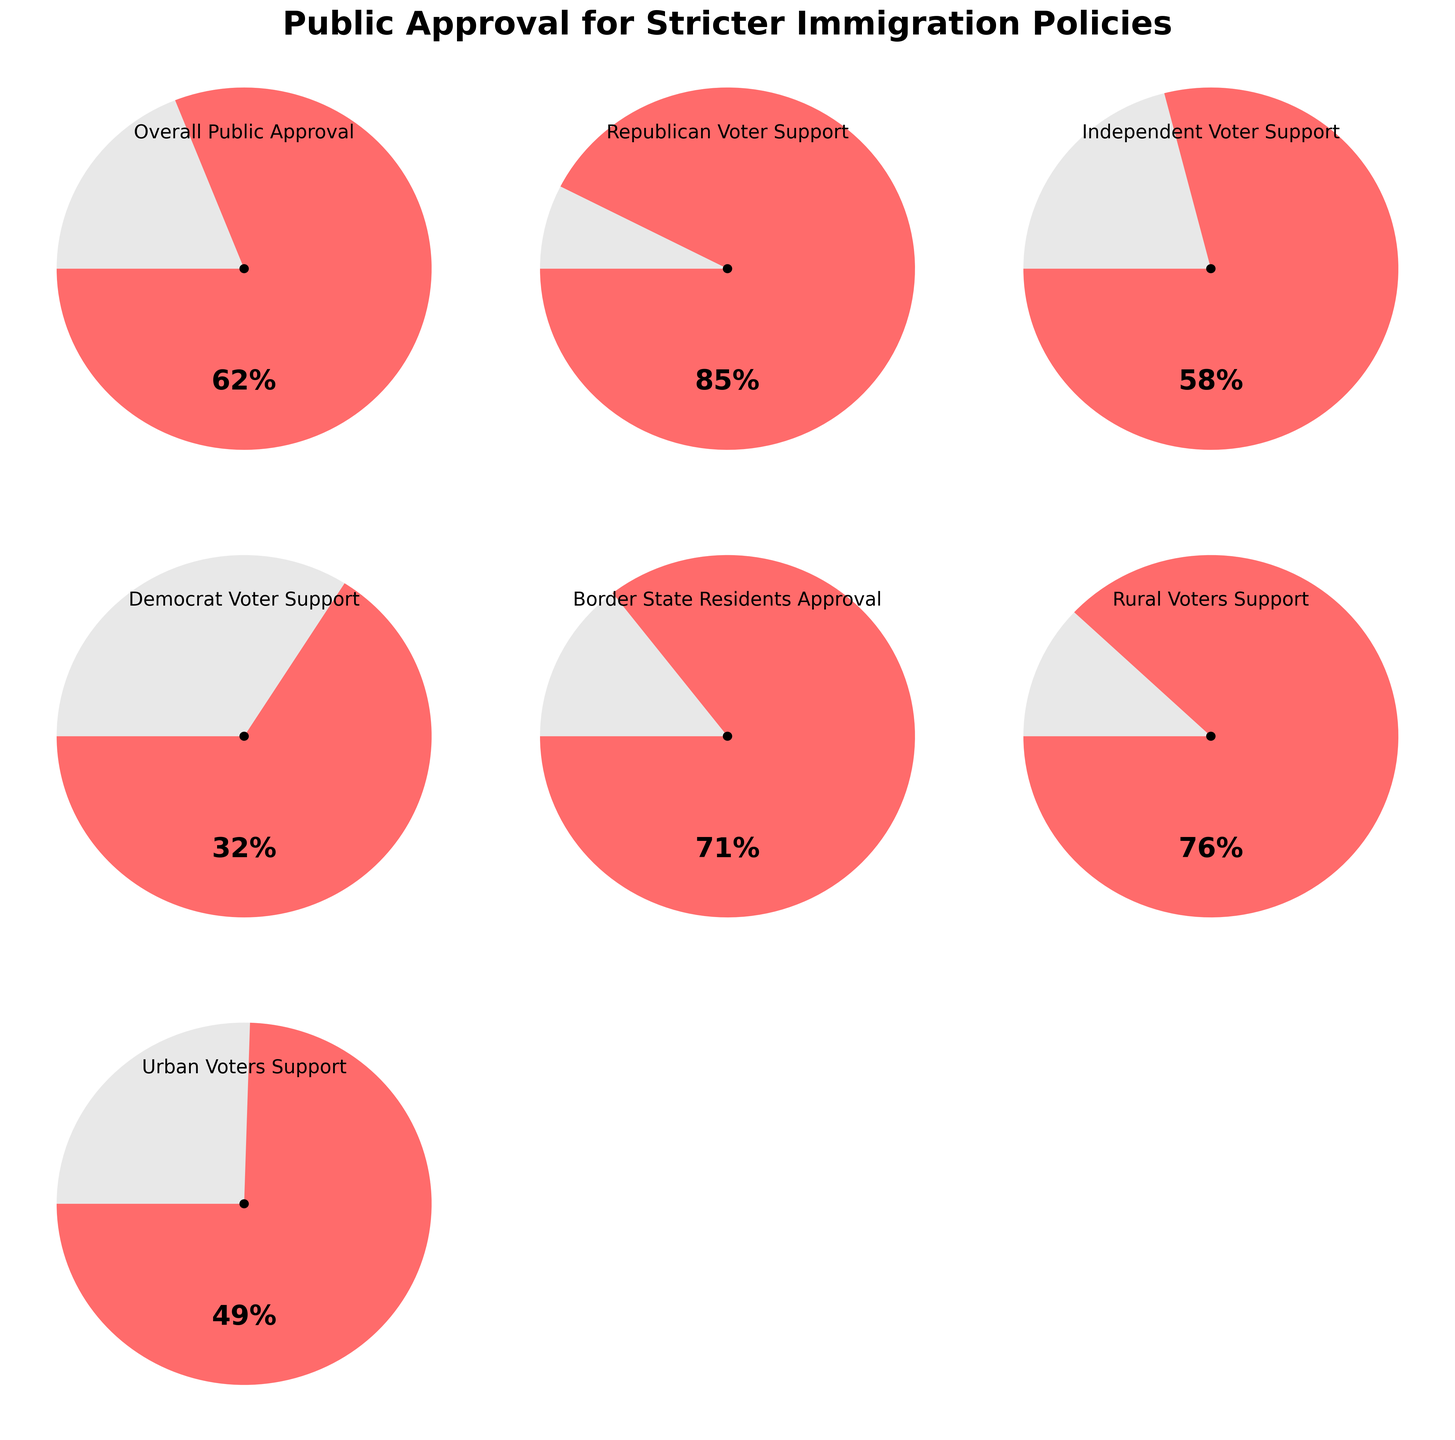What is the overall public approval rating for stricter immigration policies? The title "Overall Public Approval" and the value "62%" are provided in the figure. The question asks directly for this value.
Answer: 62% Which voter group has the highest support for stricter immigration policies? Assess the support values for each voter group: Republican (85%), Independent (58%), Democrat (32%), Border State Residents (71%), Rural Voters (76%), and Urban Voters (49%). Republican Voters have the highest support at 85%.
Answer: Republican Voters How much higher is Rural Voters' support compared to Urban Voters' support? Rural Voters' support is 76%, and Urban Voters' support is 49%. Subtract the Urban Voters' support from the Rural Voters' support (76% - 49% = 27%).
Answer: 27% Which voter group has the lowest approval rating for stricter immigration policies? Examine the support values: Republican (85%), Independent (58%), Democrat (32%), Border State Residents (71%), Rural Voters (76%), and Urban Voters (49%). Democrats have the lowest support at 32%.
Answer: Democrat Voters What is the average support for stricter immigration policies among all the groups shown? Sum all the values and divide by the number of groups: (62% + 85% + 58% + 32% + 71% + 76% + 49%) / 7 = 433 / 7 ≈ 61.857%.
Answer: 61.86% Is Independent Voters' support above or below 60%? Independent Voters' support is listed as 58%. Comparing 58% with 60%, it is below 60%.
Answer: Below Which has higher approval, Border State Residents or Rural Voters? Border State Residents have 71% support, and Rural Voters have 76% support. Comparing 71% and 76%, Rural Voters have higher approval.
Answer: Rural Voters How does the approval rating for Democrat Voters compare to the overall public approval rating? Democrat Voters' approval is 32%, while the overall public approval is 62%. The overall public approval is higher (62% - 32% = 30%).
Answer: Lower by 30% What is the median support value among all voter groups? Listing the values in ascending order: 32%, 49%, 58%, 62%, 71%, 76%, 85%. The median value is the middle value, which is 62%.
Answer: 62% What percentage of the groups have a support rating above 70%? Count the number of groups with support above 70%: Republican Voters (85%), Border State Residents (71%), and Rural Voters (76%). Out of 7 groups, 3 have support above 70%. So, 3/7 ≈ 42.86%.
Answer: 42.86% 